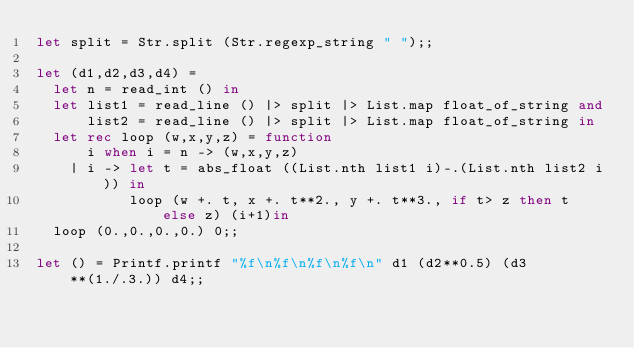Convert code to text. <code><loc_0><loc_0><loc_500><loc_500><_OCaml_>let split = Str.split (Str.regexp_string " ");;

let (d1,d2,d3,d4) =
  let n = read_int () in
  let list1 = read_line () |> split |> List.map float_of_string and
      list2 = read_line () |> split |> List.map float_of_string in
  let rec loop (w,x,y,z) = function
      i when i = n -> (w,x,y,z)
    | i -> let t = abs_float ((List.nth list1 i)-.(List.nth list2 i)) in
           loop (w +. t, x +. t**2., y +. t**3., if t> z then t else z) (i+1)in
  loop (0.,0.,0.,0.) 0;;

let () = Printf.printf "%f\n%f\n%f\n%f\n" d1 (d2**0.5) (d3**(1./.3.)) d4;;</code> 